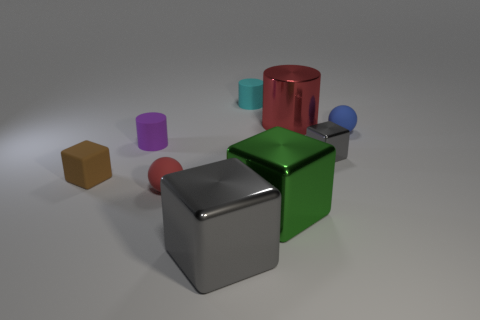Add 1 tiny yellow shiny spheres. How many objects exist? 10 Subtract all cylinders. How many objects are left? 6 Add 4 large metal blocks. How many large metal blocks are left? 6 Add 8 cyan things. How many cyan things exist? 9 Subtract 1 green cubes. How many objects are left? 8 Subtract all brown matte blocks. Subtract all large green metallic objects. How many objects are left? 7 